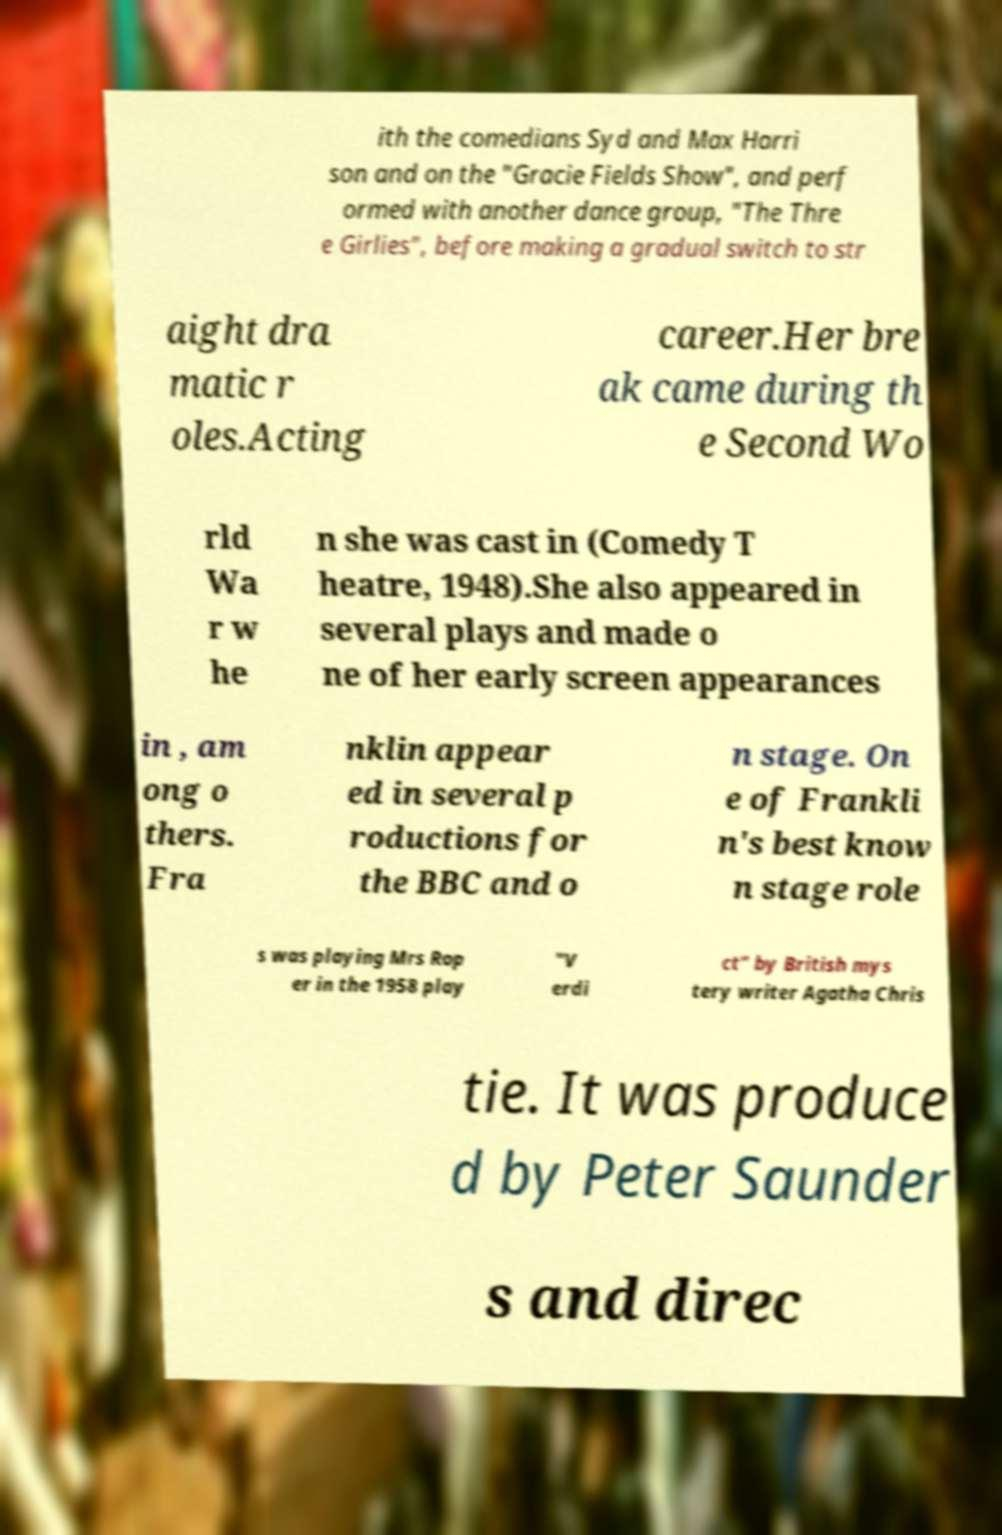There's text embedded in this image that I need extracted. Can you transcribe it verbatim? ith the comedians Syd and Max Harri son and on the "Gracie Fields Show", and perf ormed with another dance group, "The Thre e Girlies", before making a gradual switch to str aight dra matic r oles.Acting career.Her bre ak came during th e Second Wo rld Wa r w he n she was cast in (Comedy T heatre, 1948).She also appeared in several plays and made o ne of her early screen appearances in , am ong o thers. Fra nklin appear ed in several p roductions for the BBC and o n stage. On e of Frankli n's best know n stage role s was playing Mrs Rop er in the 1958 play "V erdi ct" by British mys tery writer Agatha Chris tie. It was produce d by Peter Saunder s and direc 